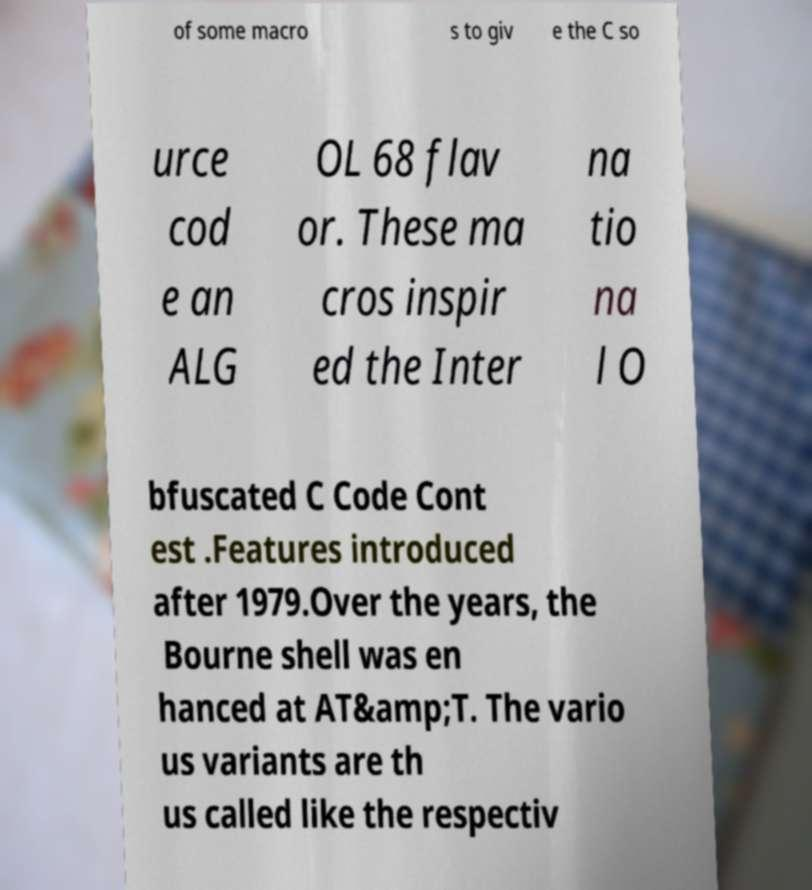There's text embedded in this image that I need extracted. Can you transcribe it verbatim? of some macro s to giv e the C so urce cod e an ALG OL 68 flav or. These ma cros inspir ed the Inter na tio na l O bfuscated C Code Cont est .Features introduced after 1979.Over the years, the Bourne shell was en hanced at AT&amp;T. The vario us variants are th us called like the respectiv 